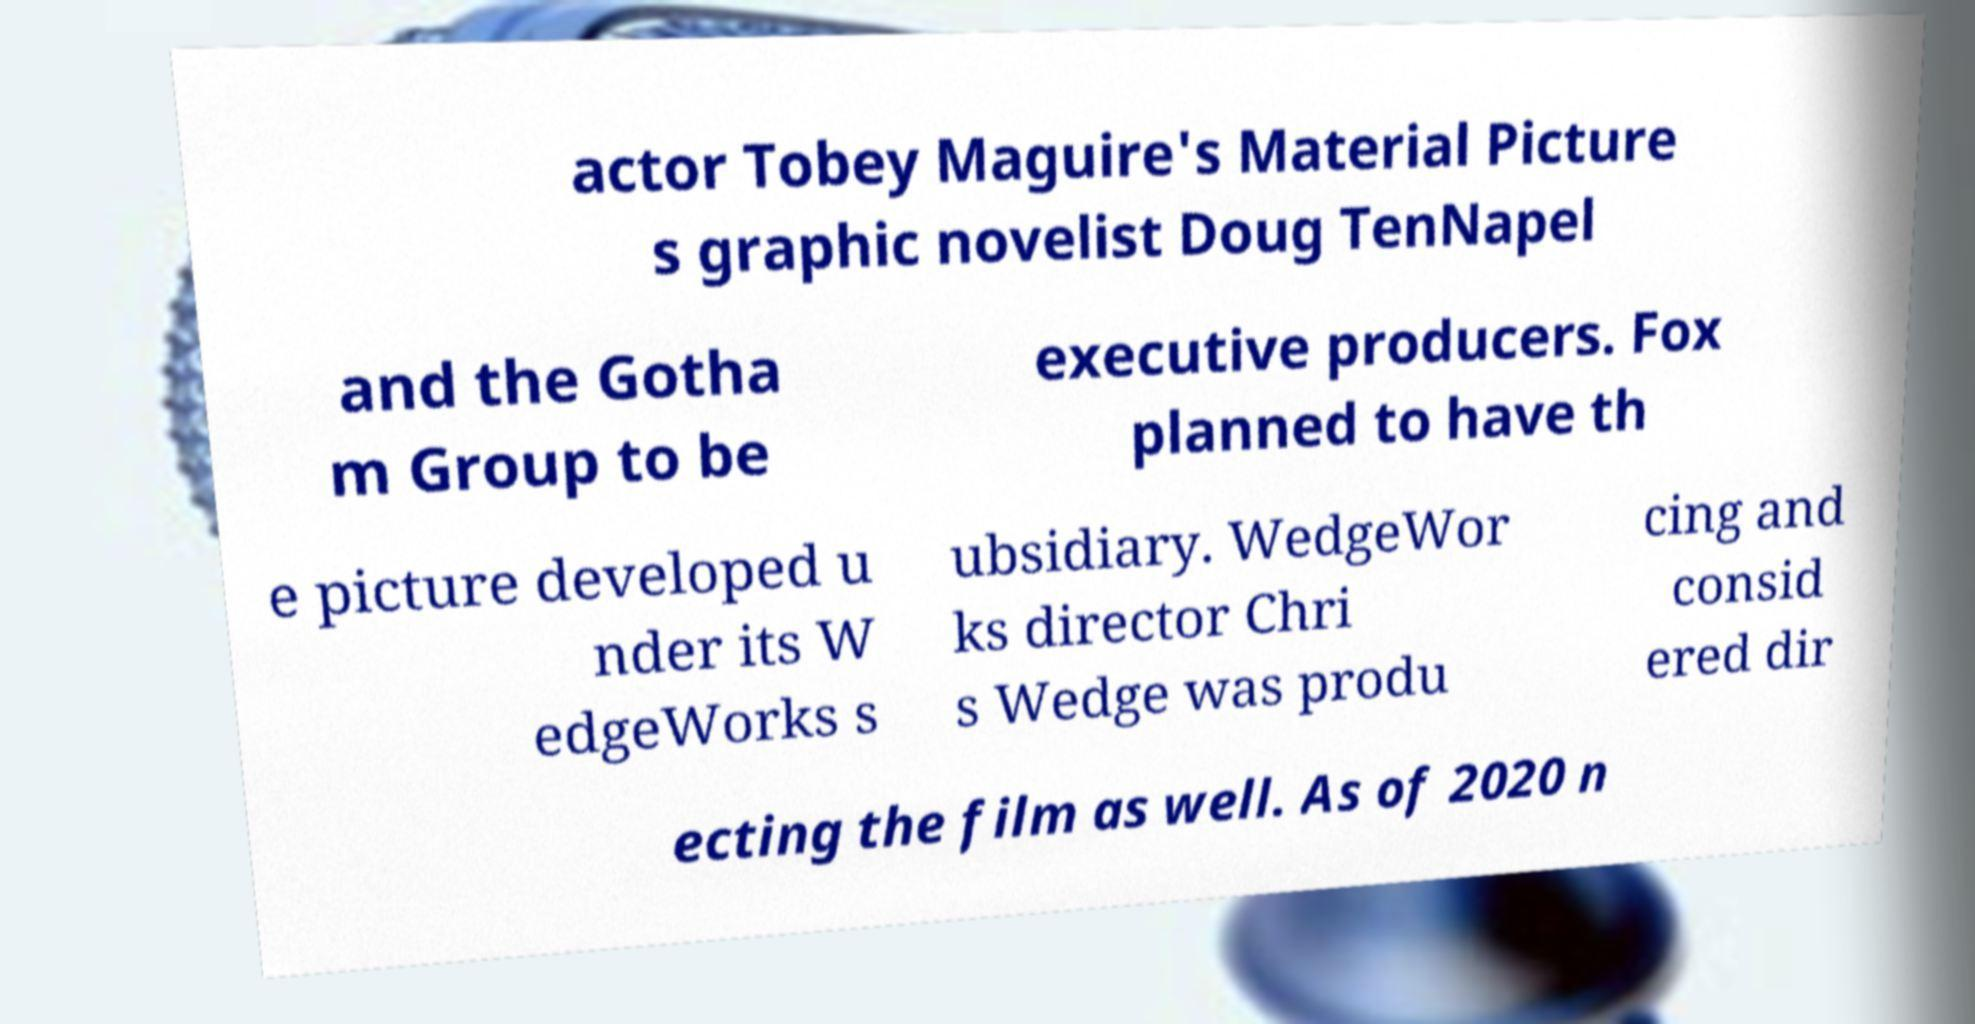I need the written content from this picture converted into text. Can you do that? actor Tobey Maguire's Material Picture s graphic novelist Doug TenNapel and the Gotha m Group to be executive producers. Fox planned to have th e picture developed u nder its W edgeWorks s ubsidiary. WedgeWor ks director Chri s Wedge was produ cing and consid ered dir ecting the film as well. As of 2020 n 